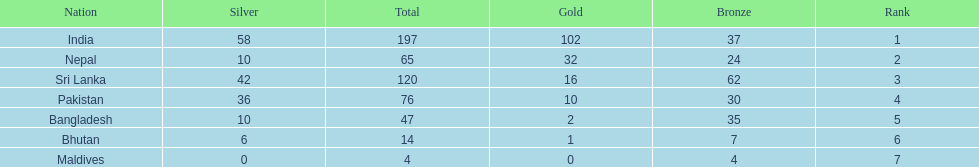Would you be able to parse every entry in this table? {'header': ['Nation', 'Silver', 'Total', 'Gold', 'Bronze', 'Rank'], 'rows': [['India', '58', '197', '102', '37', '1'], ['Nepal', '10', '65', '32', '24', '2'], ['Sri Lanka', '42', '120', '16', '62', '3'], ['Pakistan', '36', '76', '10', '30', '4'], ['Bangladesh', '10', '47', '2', '35', '5'], ['Bhutan', '6', '14', '1', '7', '6'], ['Maldives', '0', '4', '0', '4', '7']]} How many gold medals were awarded between all 7 nations? 163. 